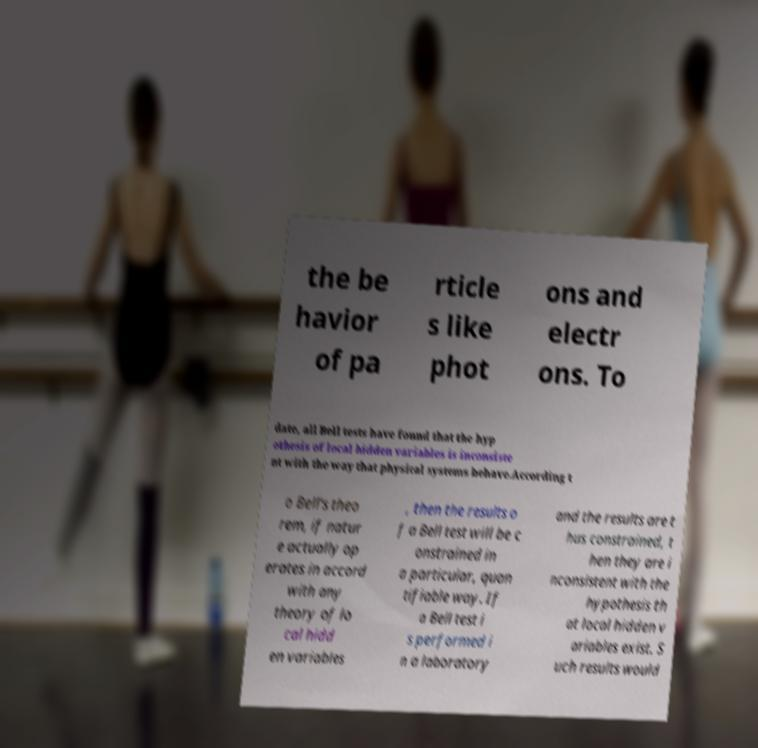Please read and relay the text visible in this image. What does it say? the be havior of pa rticle s like phot ons and electr ons. To date, all Bell tests have found that the hyp othesis of local hidden variables is inconsiste nt with the way that physical systems behave.According t o Bell's theo rem, if natur e actually op erates in accord with any theory of lo cal hidd en variables , then the results o f a Bell test will be c onstrained in a particular, quan tifiable way. If a Bell test i s performed i n a laboratory and the results are t hus constrained, t hen they are i nconsistent with the hypothesis th at local hidden v ariables exist. S uch results would 